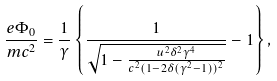<formula> <loc_0><loc_0><loc_500><loc_500>\frac { e \Phi _ { 0 } } { m c ^ { 2 } } = \frac { 1 } { \gamma } \left \{ \frac { 1 } { \sqrt { 1 - \frac { u ^ { 2 } \delta ^ { 2 } \gamma ^ { 4 } } { c ^ { 2 } ( 1 - 2 \delta ( \gamma ^ { 2 } - 1 ) ) ^ { 2 } } } } - 1 \right \} ,</formula> 